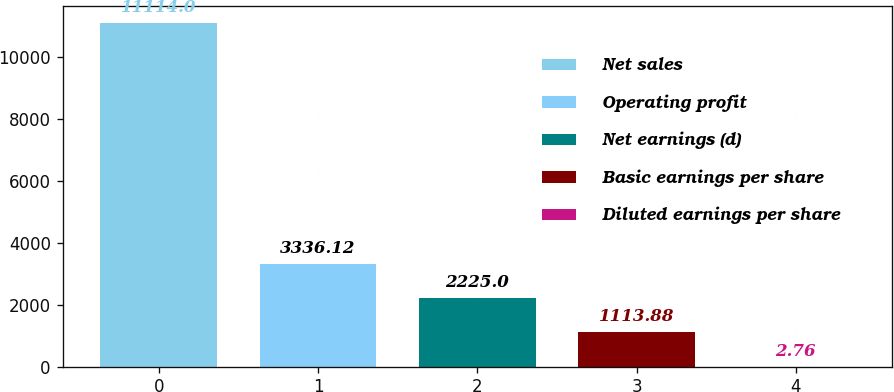<chart> <loc_0><loc_0><loc_500><loc_500><bar_chart><fcel>Net sales<fcel>Operating profit<fcel>Net earnings (d)<fcel>Basic earnings per share<fcel>Diluted earnings per share<nl><fcel>11114<fcel>3336.12<fcel>2225<fcel>1113.88<fcel>2.76<nl></chart> 